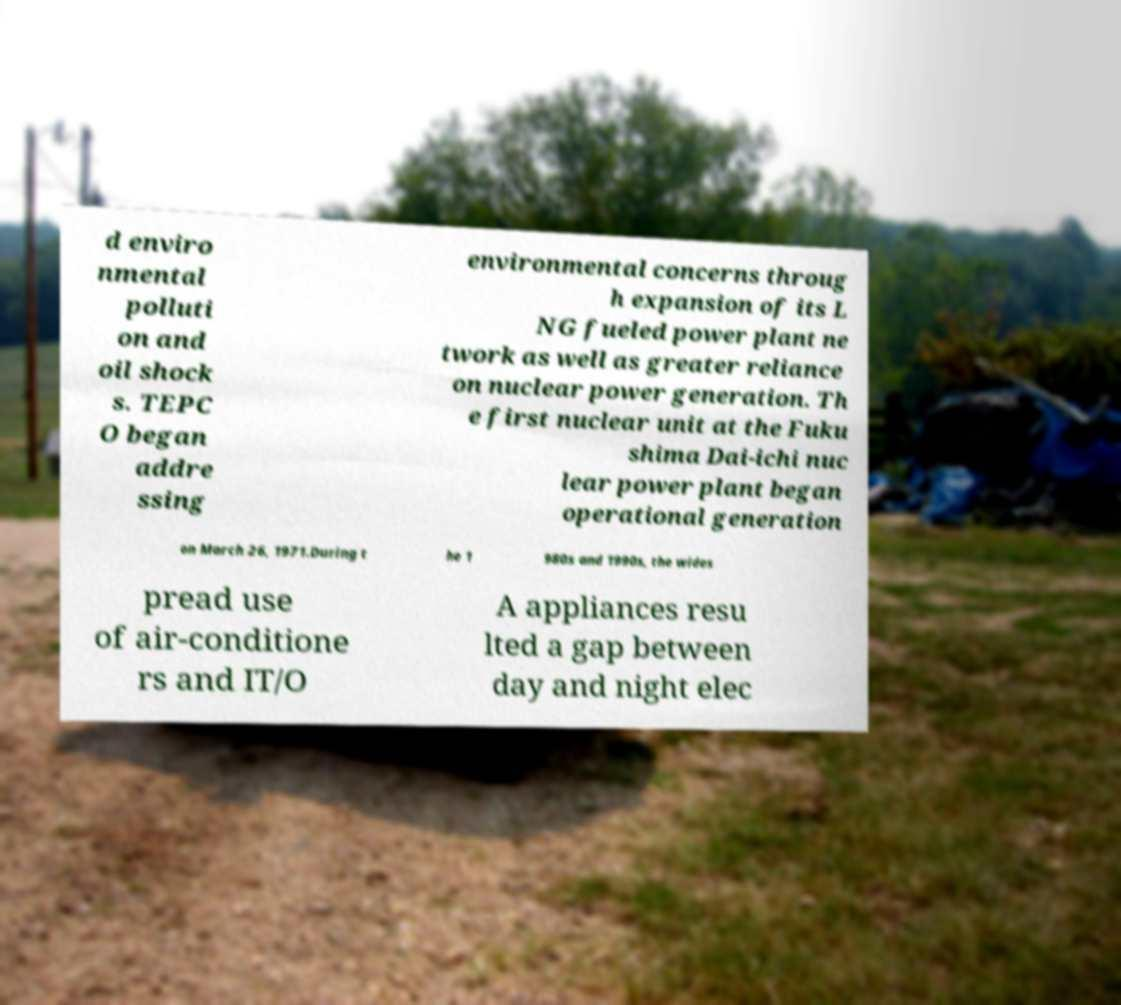What messages or text are displayed in this image? I need them in a readable, typed format. d enviro nmental polluti on and oil shock s. TEPC O began addre ssing environmental concerns throug h expansion of its L NG fueled power plant ne twork as well as greater reliance on nuclear power generation. Th e first nuclear unit at the Fuku shima Dai-ichi nuc lear power plant began operational generation on March 26, 1971.During t he 1 980s and 1990s, the wides pread use of air-conditione rs and IT/O A appliances resu lted a gap between day and night elec 